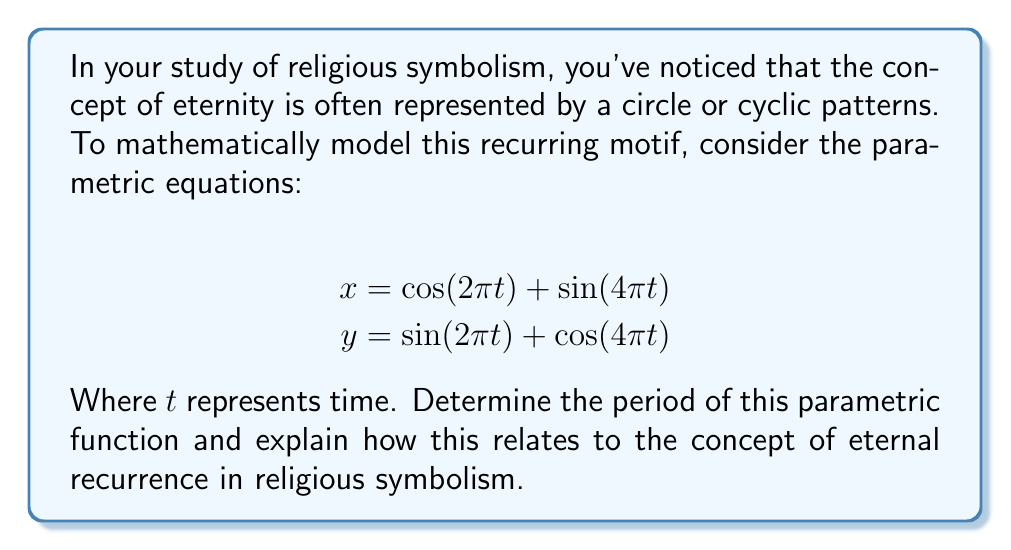Give your solution to this math problem. To determine the period of this parametric function, we need to find the smallest positive value of $T$ such that both $x(t+T) = x(t)$ and $y(t+T) = y(t)$ for all $t$.

1) First, let's consider the $x$ equation:
   $$x = \cos(2\pi t) + \sin(4\pi t)$$
   
   The period of $\cos(2\pi t)$ is 1, and the period of $\sin(4\pi t)$ is $\frac{1}{2}$.

2) For the $y$ equation:
   $$y = \sin(2\pi t) + \cos(4\pi t)$$
   
   The period of $\sin(2\pi t)$ is 1, and the period of $\cos(4\pi t)$ is $\frac{1}{2}$.

3) To find the period of the entire function, we need to find the least common multiple (LCM) of these individual periods:

   $LCM(1, \frac{1}{2}) = 1$

4) Therefore, the period of the parametric function is 1.

This mathematical result can be interpreted in the context of religious symbolism as follows:

The period of 1 represents a complete cycle, mirroring the concept of eternal recurrence or cyclical time found in many religious traditions. Just as the parametric equations return to their initial values after one complete cycle, many religious motifs suggest that events or states of being repeat in an endless loop.

The combination of functions with different frequencies (2π and 4π) within each equation could be seen as representing the interplay of different cyclical phenomena in religious cosmology, such as the cycle of birth, death, and rebirth, or the repetition of cosmic epochs.

The fact that these diverse elements combine to create a unified cycle with a period of 1 could be interpreted as symbolizing the ultimate unity or harmony underlying apparent complexity in religious worldviews.
Answer: The period of the parametric function is 1, which can be interpreted as representing a complete cycle in the context of eternal recurrence in religious symbolism. 